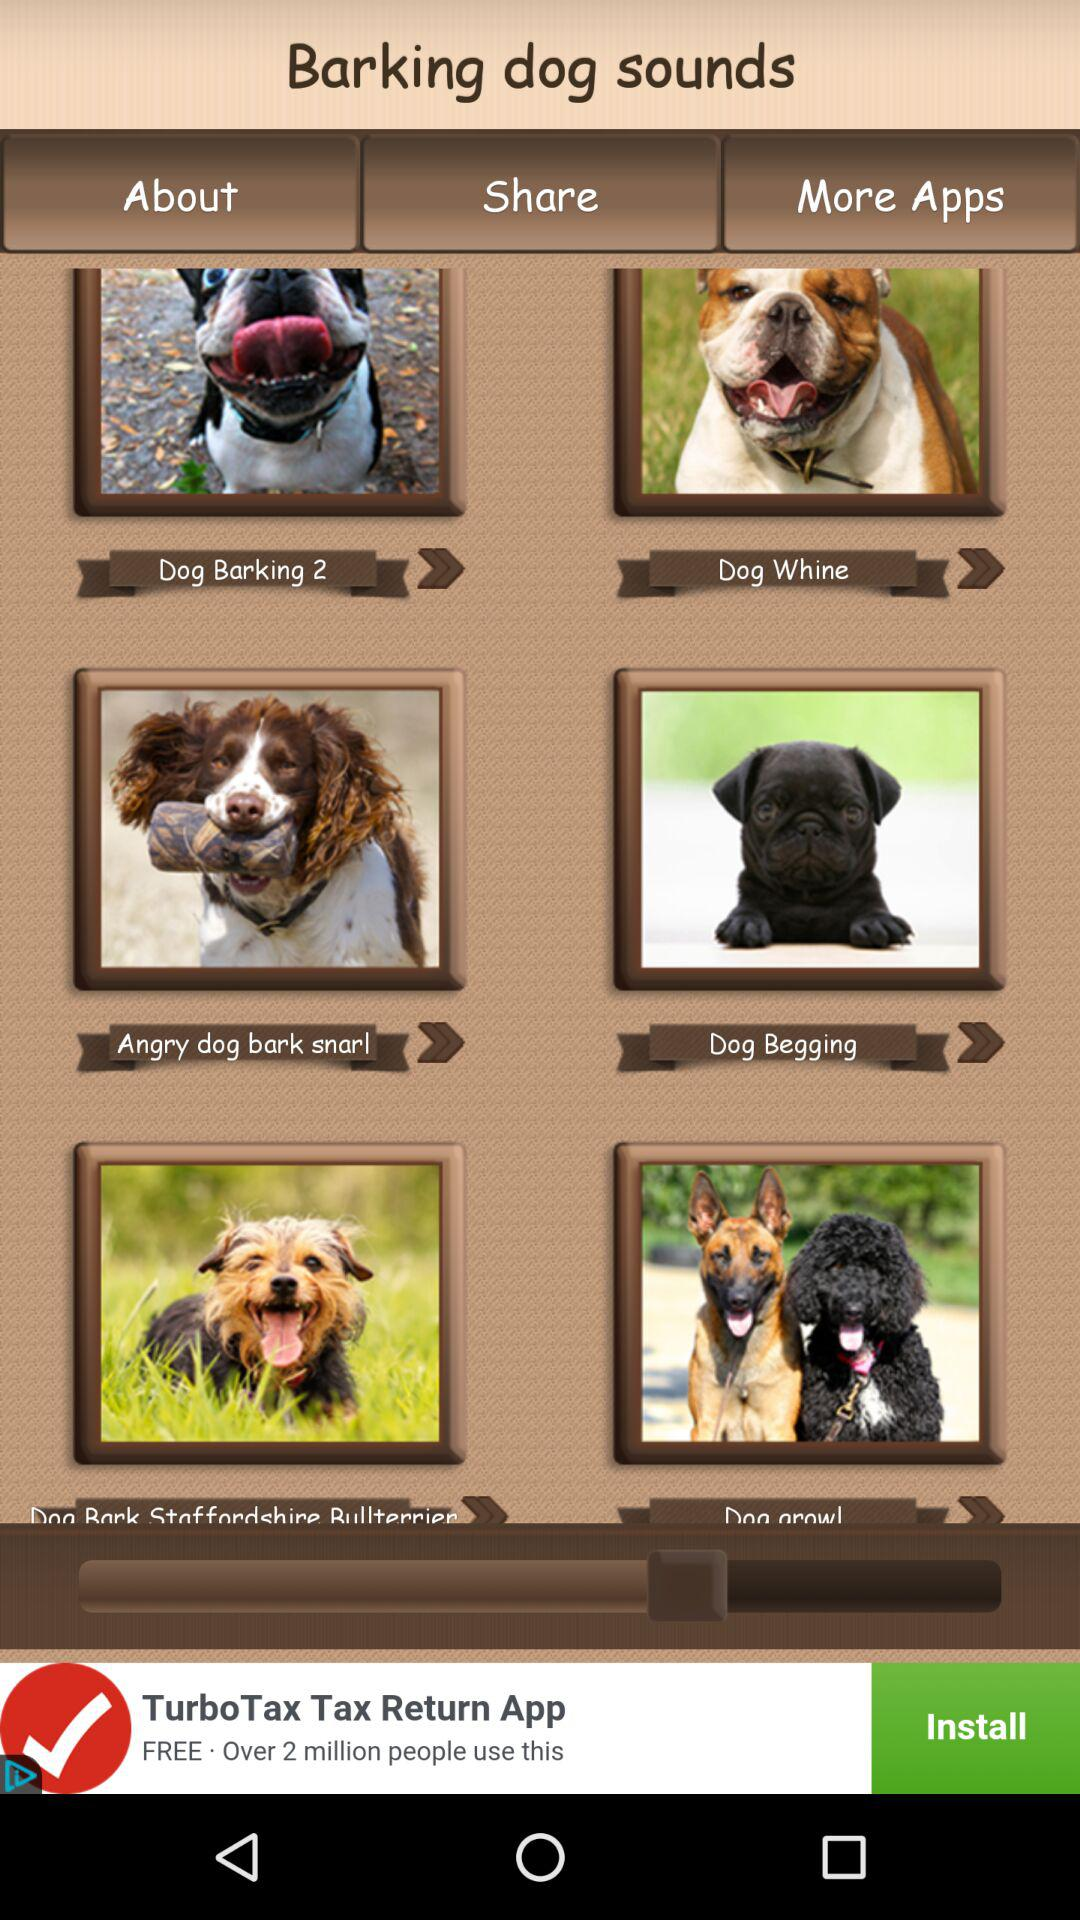What is the application name? The name of the application is "Barking dog sounds". 